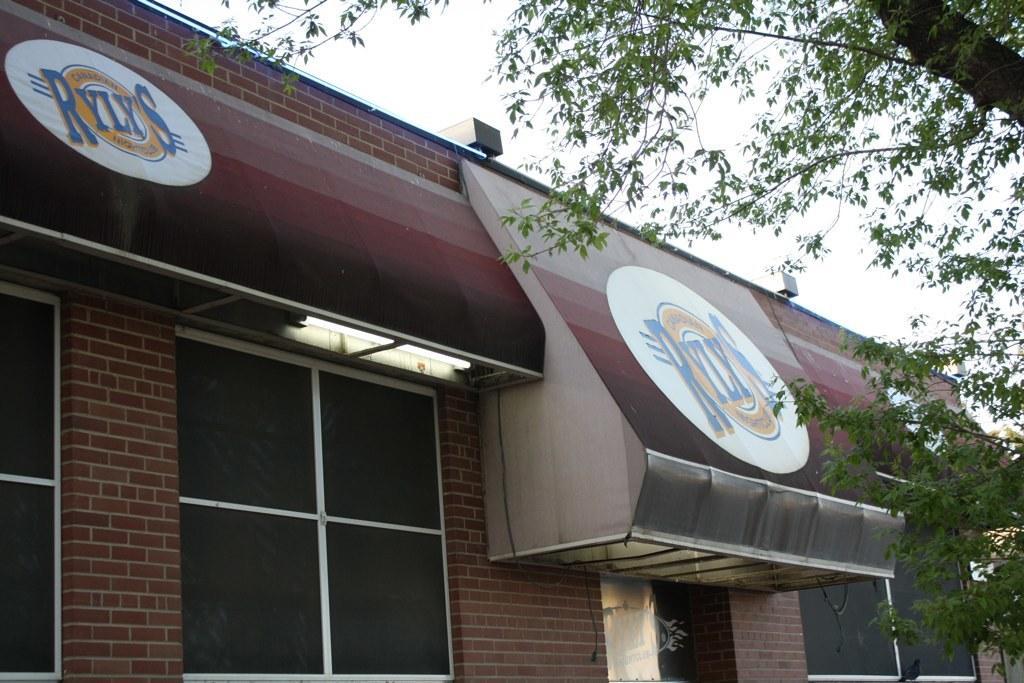In one or two sentences, can you explain what this image depicts? In this image I can see a tree which is green and black in color and a building which is made up of bricks is brown in color. I can see few windows of the building and few boards which are brown, yellow, white and blue in color. In the background I can see the sky. 